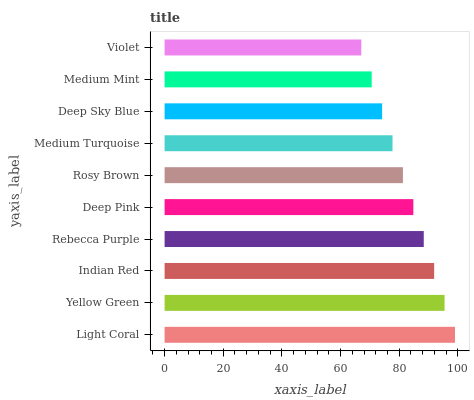Is Violet the minimum?
Answer yes or no. Yes. Is Light Coral the maximum?
Answer yes or no. Yes. Is Yellow Green the minimum?
Answer yes or no. No. Is Yellow Green the maximum?
Answer yes or no. No. Is Light Coral greater than Yellow Green?
Answer yes or no. Yes. Is Yellow Green less than Light Coral?
Answer yes or no. Yes. Is Yellow Green greater than Light Coral?
Answer yes or no. No. Is Light Coral less than Yellow Green?
Answer yes or no. No. Is Deep Pink the high median?
Answer yes or no. Yes. Is Rosy Brown the low median?
Answer yes or no. Yes. Is Rosy Brown the high median?
Answer yes or no. No. Is Deep Pink the low median?
Answer yes or no. No. 